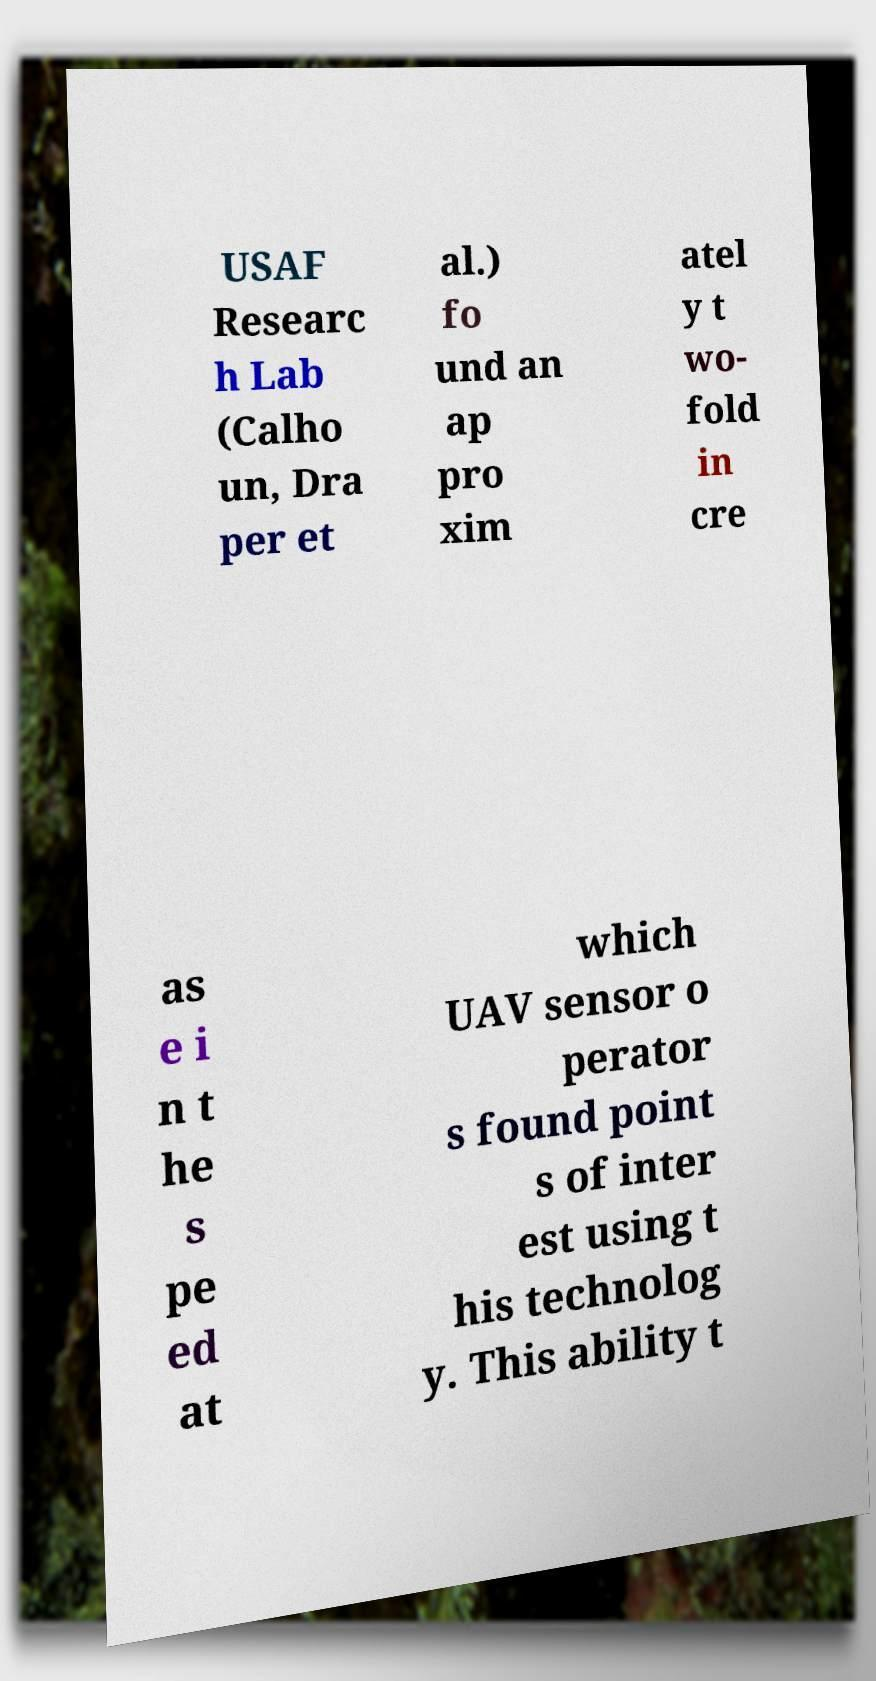Please read and relay the text visible in this image. What does it say? USAF Researc h Lab (Calho un, Dra per et al.) fo und an ap pro xim atel y t wo- fold in cre as e i n t he s pe ed at which UAV sensor o perator s found point s of inter est using t his technolog y. This ability t 